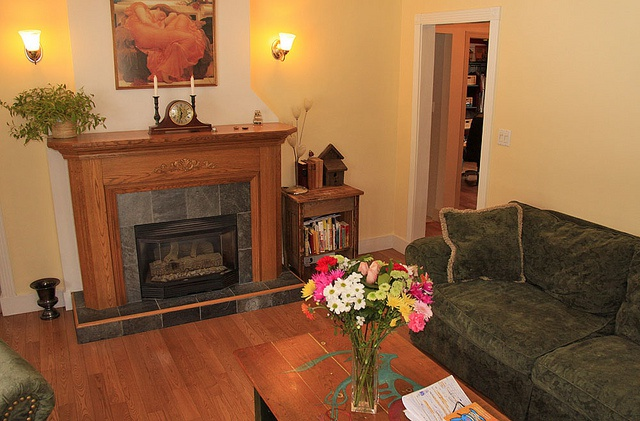Describe the objects in this image and their specific colors. I can see couch in orange, black, and gray tones, potted plant in orange, olive, tan, and maroon tones, couch in orange, gray, and black tones, vase in orange, olive, maroon, brown, and gray tones, and book in orange, red, and brown tones in this image. 